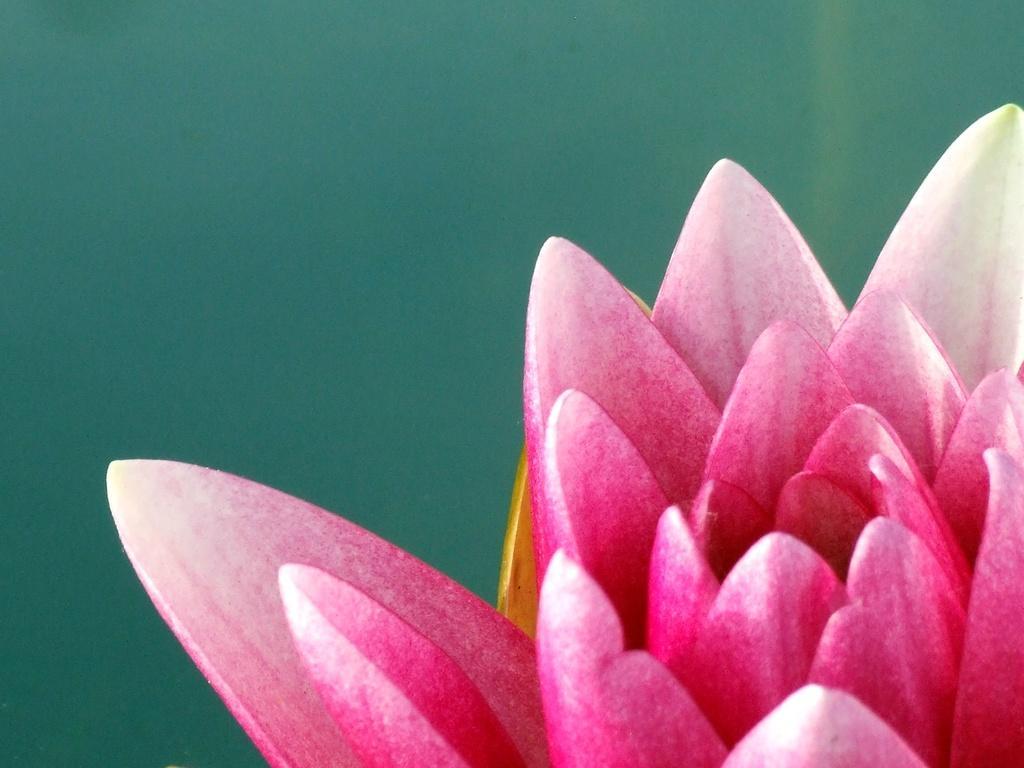Could you give a brief overview of what you see in this image? This image consists of a flower in pink color. In the background, there is green color. 